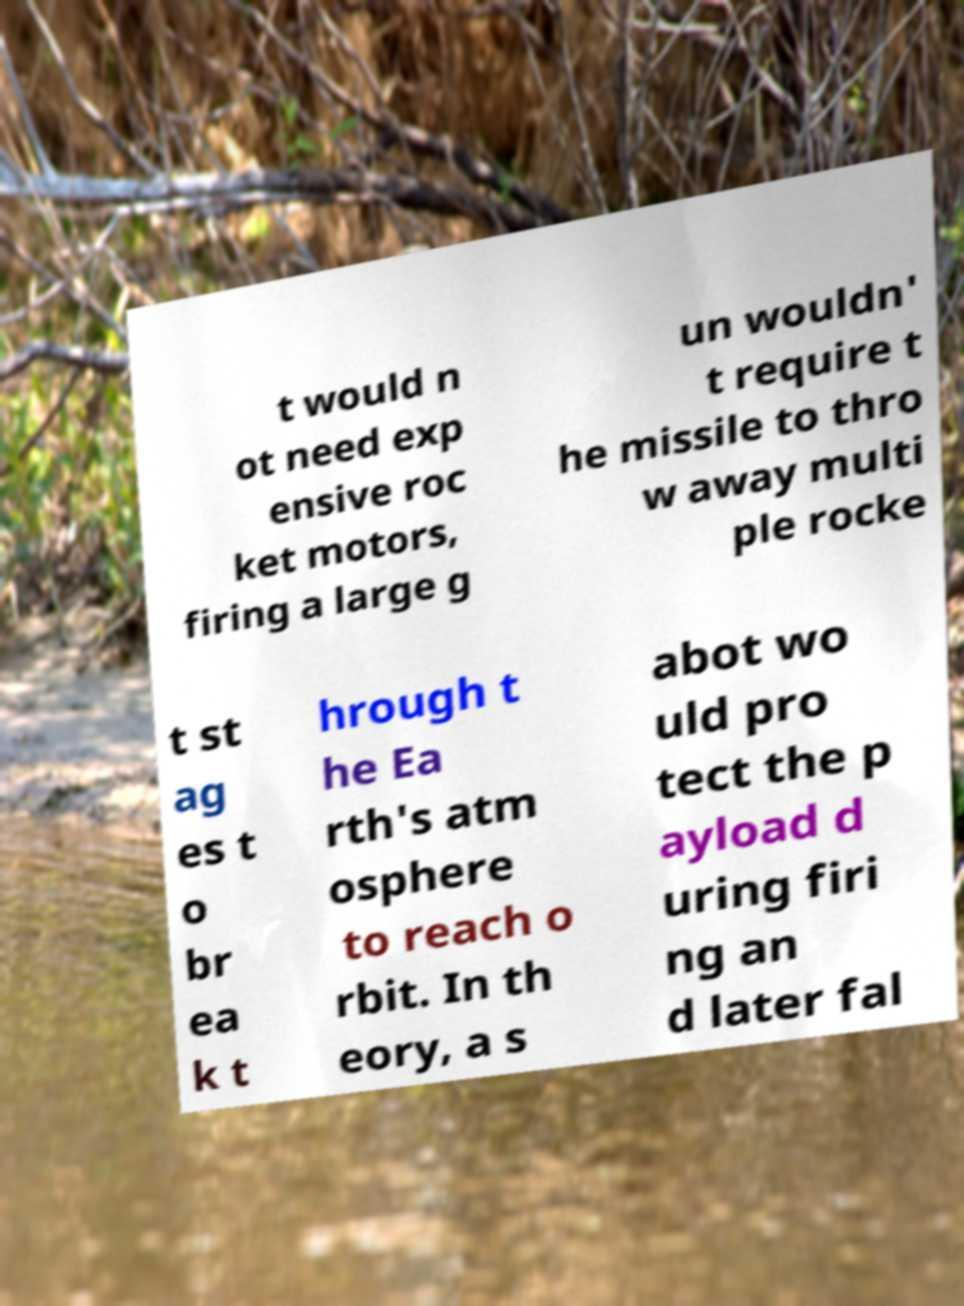Could you extract and type out the text from this image? t would n ot need exp ensive roc ket motors, firing a large g un wouldn' t require t he missile to thro w away multi ple rocke t st ag es t o br ea k t hrough t he Ea rth's atm osphere to reach o rbit. In th eory, a s abot wo uld pro tect the p ayload d uring firi ng an d later fal 